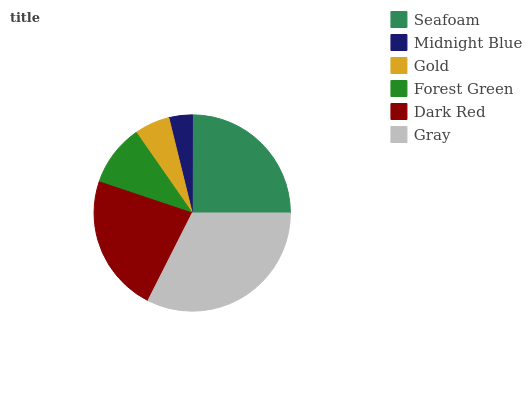Is Midnight Blue the minimum?
Answer yes or no. Yes. Is Gray the maximum?
Answer yes or no. Yes. Is Gold the minimum?
Answer yes or no. No. Is Gold the maximum?
Answer yes or no. No. Is Gold greater than Midnight Blue?
Answer yes or no. Yes. Is Midnight Blue less than Gold?
Answer yes or no. Yes. Is Midnight Blue greater than Gold?
Answer yes or no. No. Is Gold less than Midnight Blue?
Answer yes or no. No. Is Dark Red the high median?
Answer yes or no. Yes. Is Forest Green the low median?
Answer yes or no. Yes. Is Midnight Blue the high median?
Answer yes or no. No. Is Midnight Blue the low median?
Answer yes or no. No. 